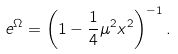<formula> <loc_0><loc_0><loc_500><loc_500>e ^ { \Omega } = \left ( 1 - \frac { 1 } { 4 } \mu ^ { 2 } x ^ { 2 } \right ) ^ { - 1 } .</formula> 